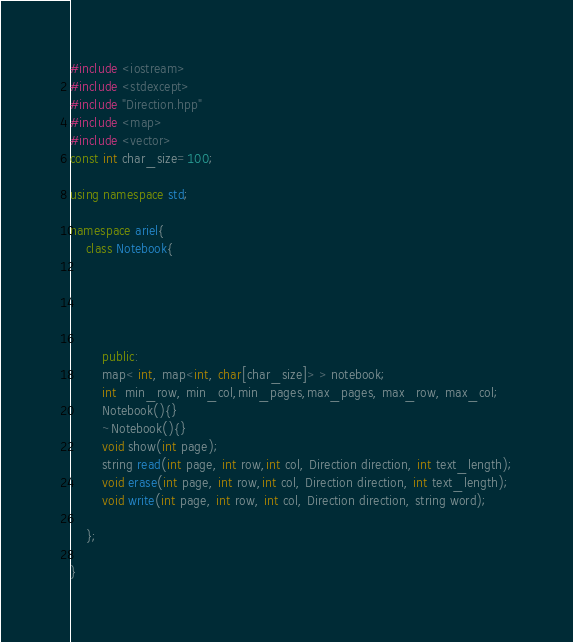<code> <loc_0><loc_0><loc_500><loc_500><_C++_>#include <iostream>
#include <stdexcept>
#include "Direction.hpp"
#include <map>
#include <vector>
const int char_size=100;

using namespace std;

namespace ariel{
    class Notebook{

       
       


        public:
        map< int, map<int, char[char_size]> > notebook;
        int  min_row, min_col,min_pages,max_pages, max_row, max_col;
        Notebook(){}
        ~Notebook(){}
        void show(int page);
        string read(int page, int row,int col, Direction direction, int text_length);
        void erase(int page, int row,int col, Direction direction, int text_length);
        void write(int page, int row, int col, Direction direction, string word);
        
    };
    
}</code> 